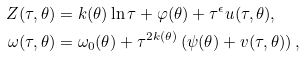Convert formula to latex. <formula><loc_0><loc_0><loc_500><loc_500>Z ( \tau , \theta ) & = k ( \theta ) \ln \tau + \varphi ( \theta ) + \tau ^ { \epsilon } u ( \tau , \theta ) , \\ \omega ( \tau , \theta ) & = \omega _ { 0 } ( \theta ) + \tau ^ { 2 k ( \theta ) } \left ( \psi ( \theta ) + v ( \tau , \theta ) \right ) ,</formula> 